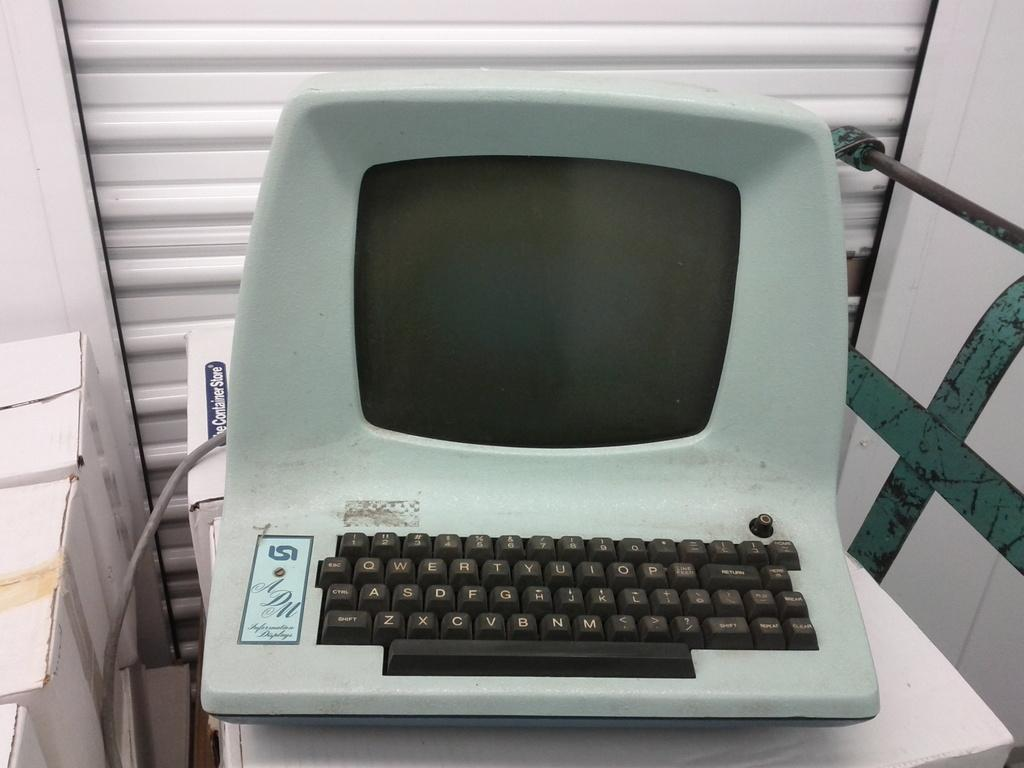<image>
Summarize the visual content of the image. A late model computer terminal is labeled with the initials ADM. 